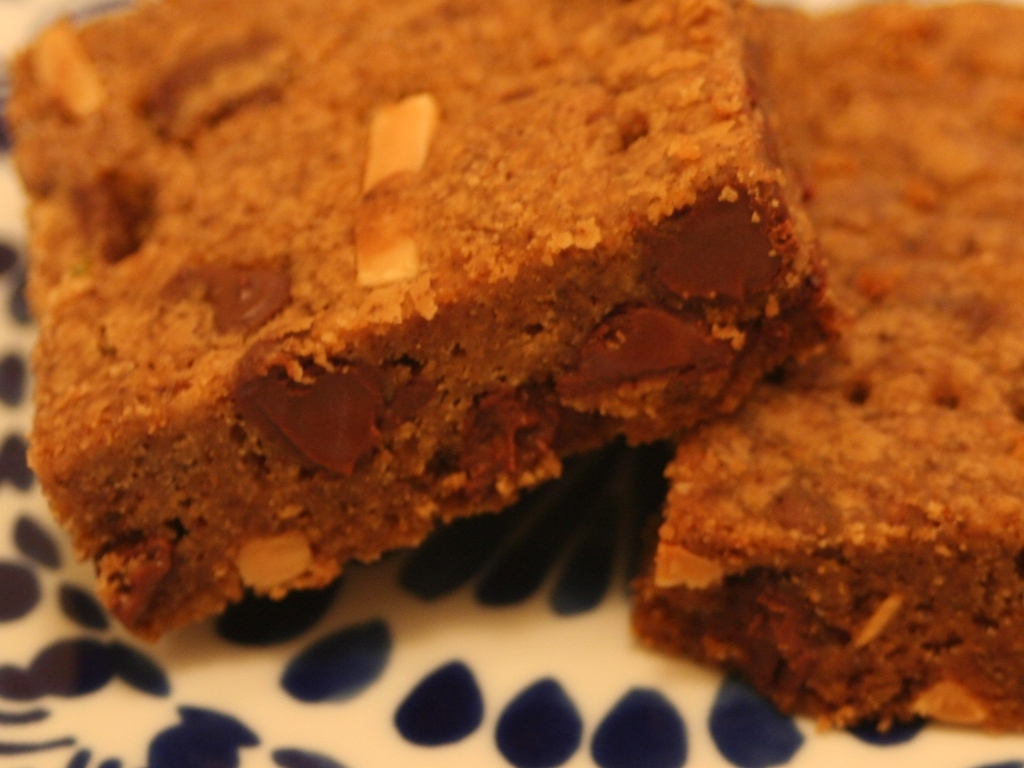Is the overall lighting of the image sufficient?
A. too dark
B. no
C. yes
Answer with the option's letter from the given choices directly.
 C. 